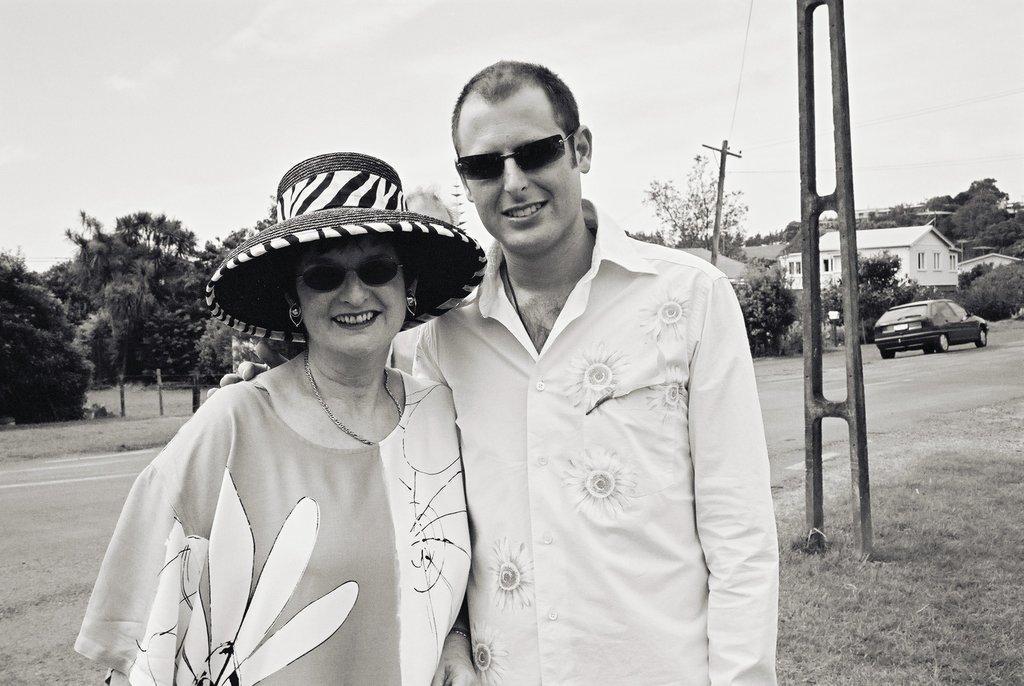In one or two sentences, can you explain what this image depicts? In this picture we can see a man wore goggles and a woman wore goggles, hat and they are smiling, standing and at the back of them we can see the grass, car on the road, poles, buildings, trees and in the background we can see the sky. 